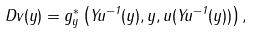Convert formula to latex. <formula><loc_0><loc_0><loc_500><loc_500>D v ( y ) = g ^ { * } _ { y } \left ( Y u ^ { - 1 } ( y ) , y , u ( Y u ^ { - 1 } ( y ) ) \right ) ,</formula> 